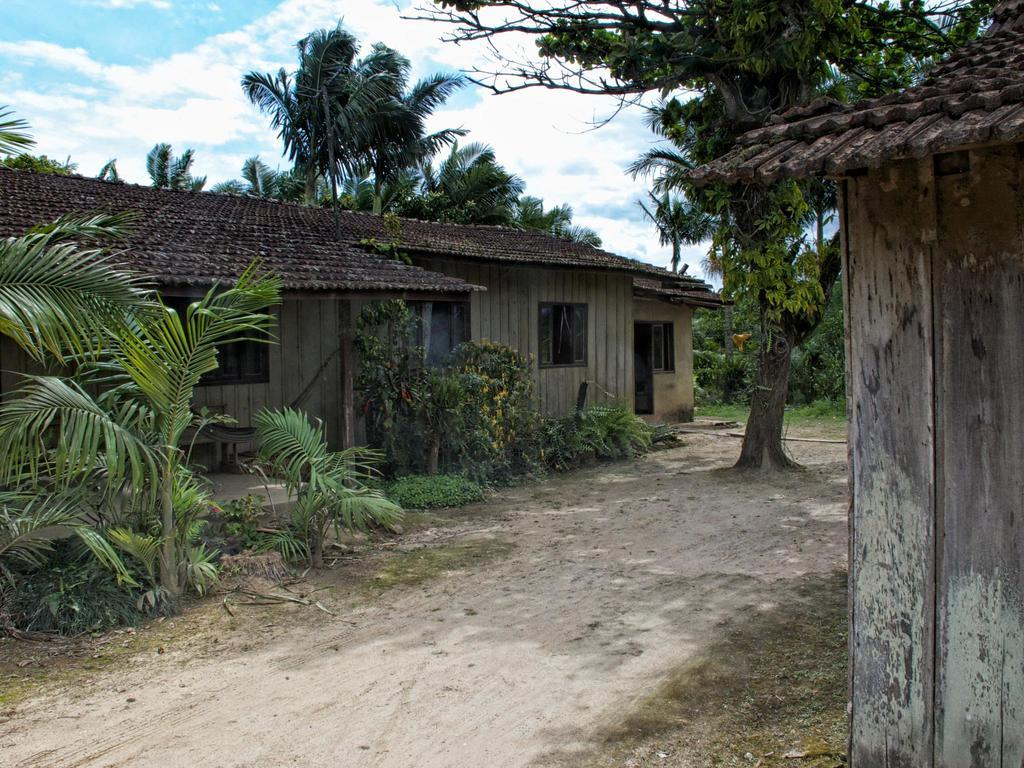What type of structures can be seen in the image? There are houses in the image. What type of vegetation is present in the image? There are trees and plants in the image. What can be seen in the background of the image? The sky is visible in the background of the image. What is the condition of the sky in the image? Clouds are present in the sky. How many pockets are visible on the trees in the image? There are no pockets present on the trees in the image, as trees do not have pockets. 